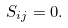Convert formula to latex. <formula><loc_0><loc_0><loc_500><loc_500>S _ { i j } = 0 .</formula> 